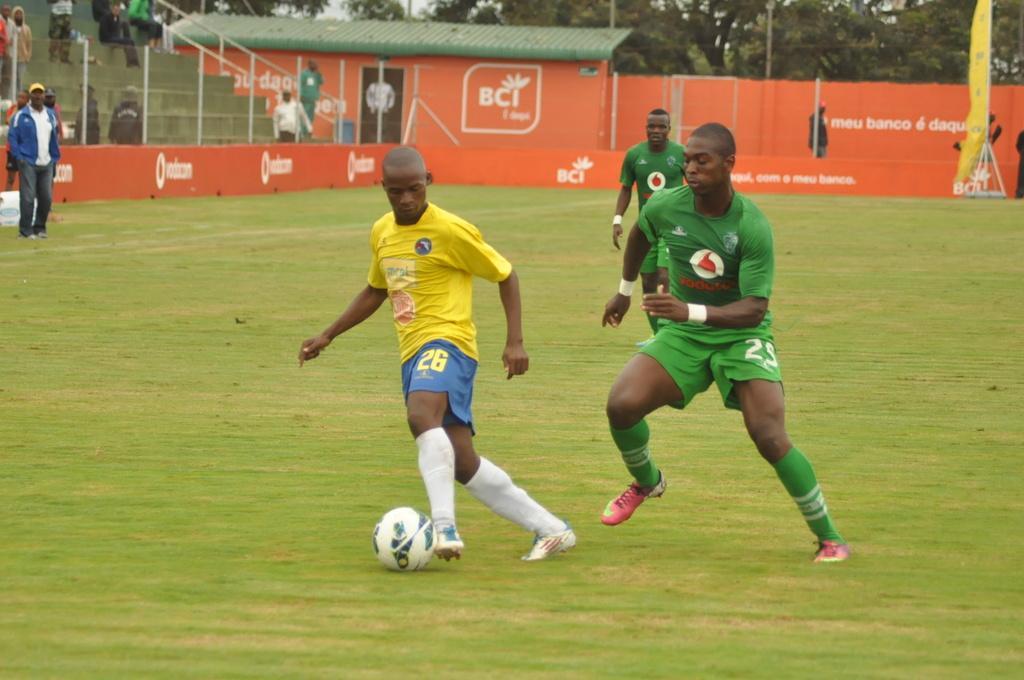Could you give a brief overview of what you see in this image? In this picture we can see a ball and three men are running on the ground and in the background we can see a group of people standing on steps, door, wall, trees. 